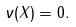Convert formula to latex. <formula><loc_0><loc_0><loc_500><loc_500>\nu ( X ) = 0 .</formula> 